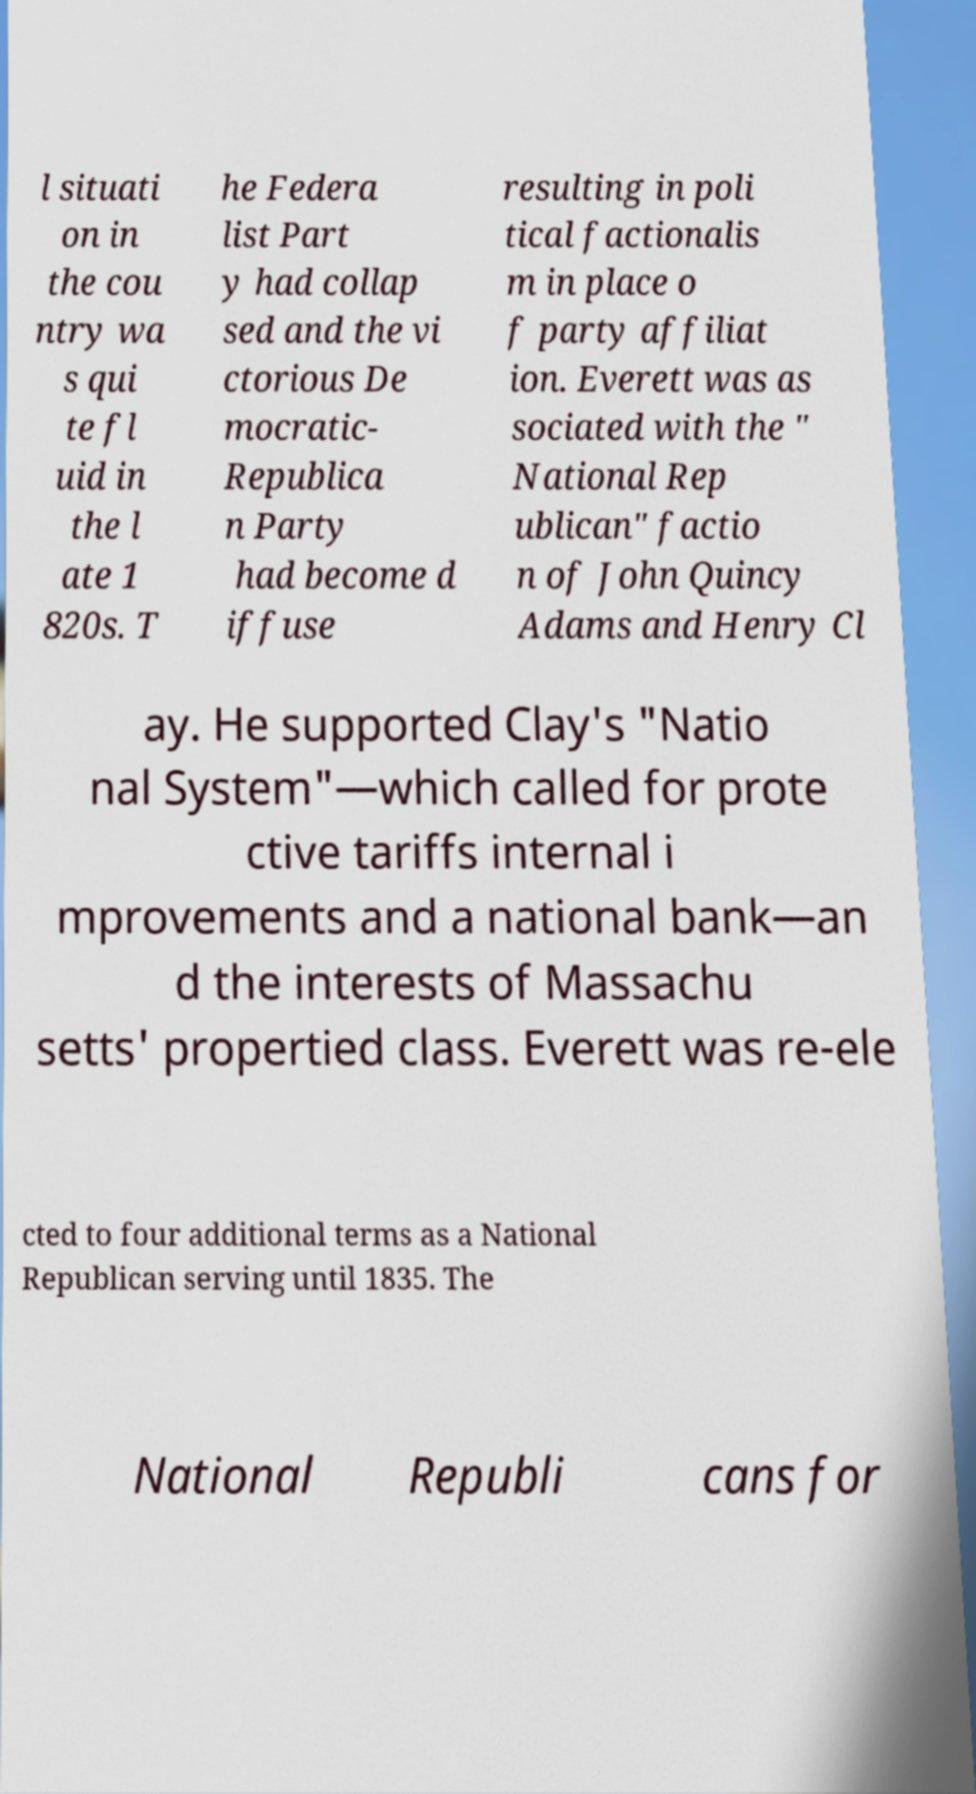Could you extract and type out the text from this image? l situati on in the cou ntry wa s qui te fl uid in the l ate 1 820s. T he Federa list Part y had collap sed and the vi ctorious De mocratic- Republica n Party had become d iffuse resulting in poli tical factionalis m in place o f party affiliat ion. Everett was as sociated with the " National Rep ublican" factio n of John Quincy Adams and Henry Cl ay. He supported Clay's "Natio nal System"—which called for prote ctive tariffs internal i mprovements and a national bank—an d the interests of Massachu setts' propertied class. Everett was re-ele cted to four additional terms as a National Republican serving until 1835. The National Republi cans for 